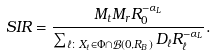<formula> <loc_0><loc_0><loc_500><loc_500>S I R = \frac { M _ { t } M _ { r } R _ { 0 } ^ { - \alpha _ { L } } } { \sum _ { \ell \colon X _ { \ell } \in \Phi \cap \mathcal { B } ( 0 , R _ { B } ) } D _ { \ell } R _ { \ell } ^ { - \alpha _ { L } } } .</formula> 